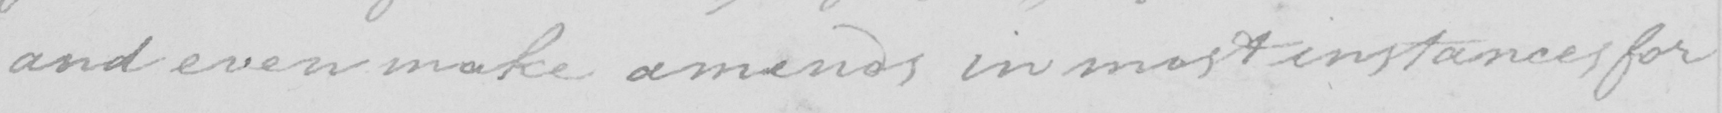Please transcribe the handwritten text in this image. and even make amends in most instances for 